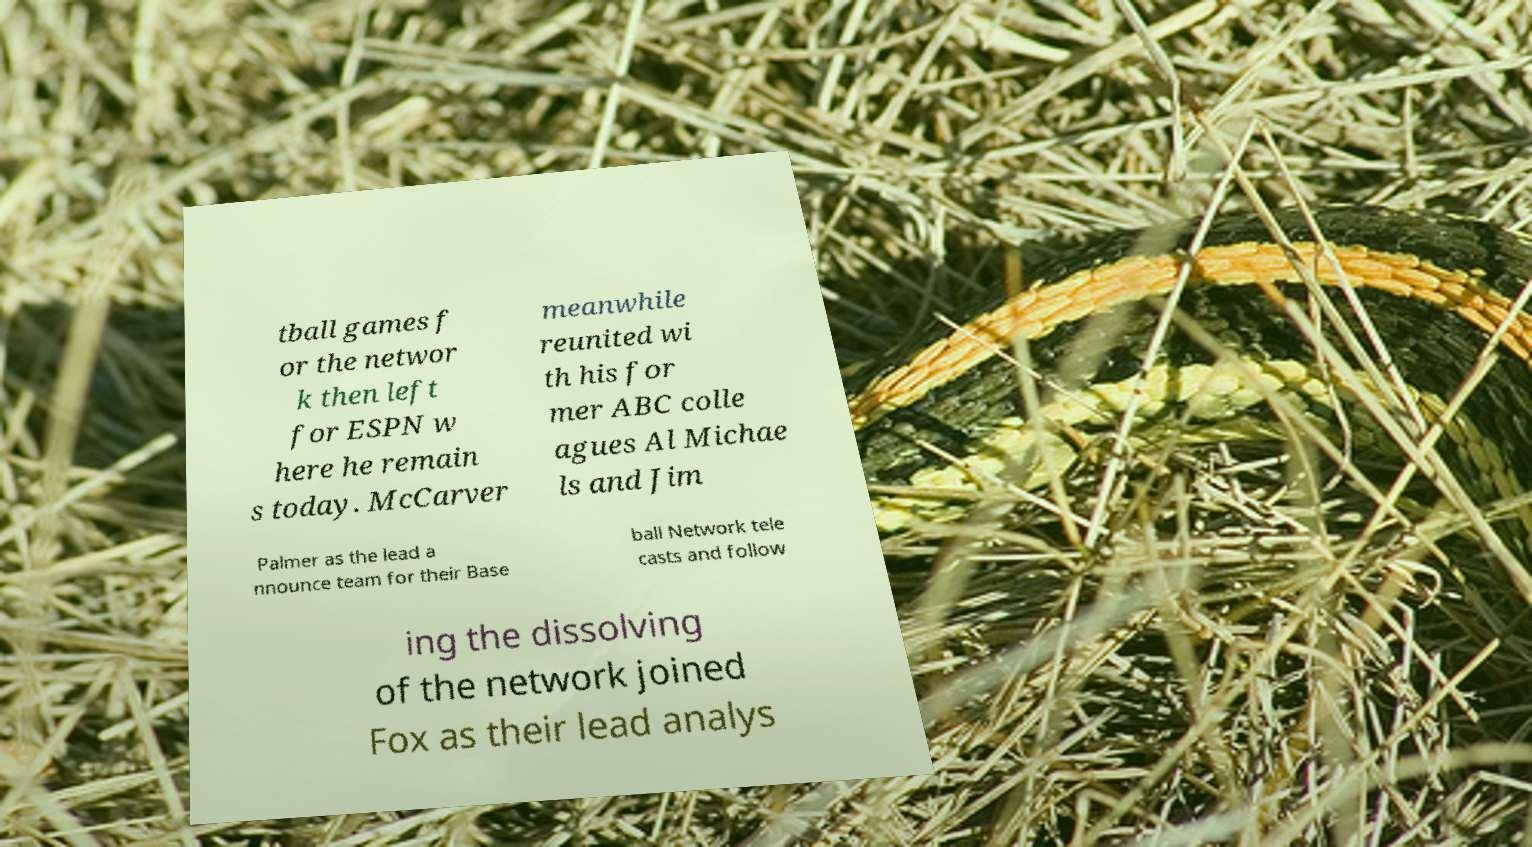Please identify and transcribe the text found in this image. tball games f or the networ k then left for ESPN w here he remain s today. McCarver meanwhile reunited wi th his for mer ABC colle agues Al Michae ls and Jim Palmer as the lead a nnounce team for their Base ball Network tele casts and follow ing the dissolving of the network joined Fox as their lead analys 